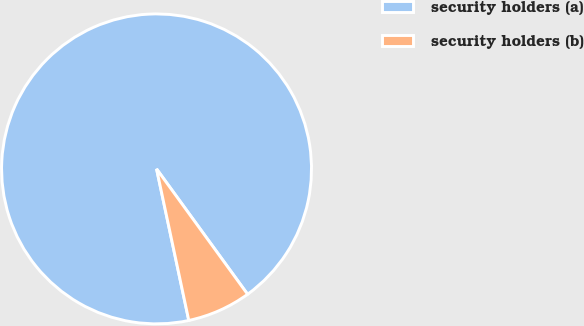Convert chart. <chart><loc_0><loc_0><loc_500><loc_500><pie_chart><fcel>security holders (a)<fcel>security holders (b)<nl><fcel>93.34%<fcel>6.66%<nl></chart> 